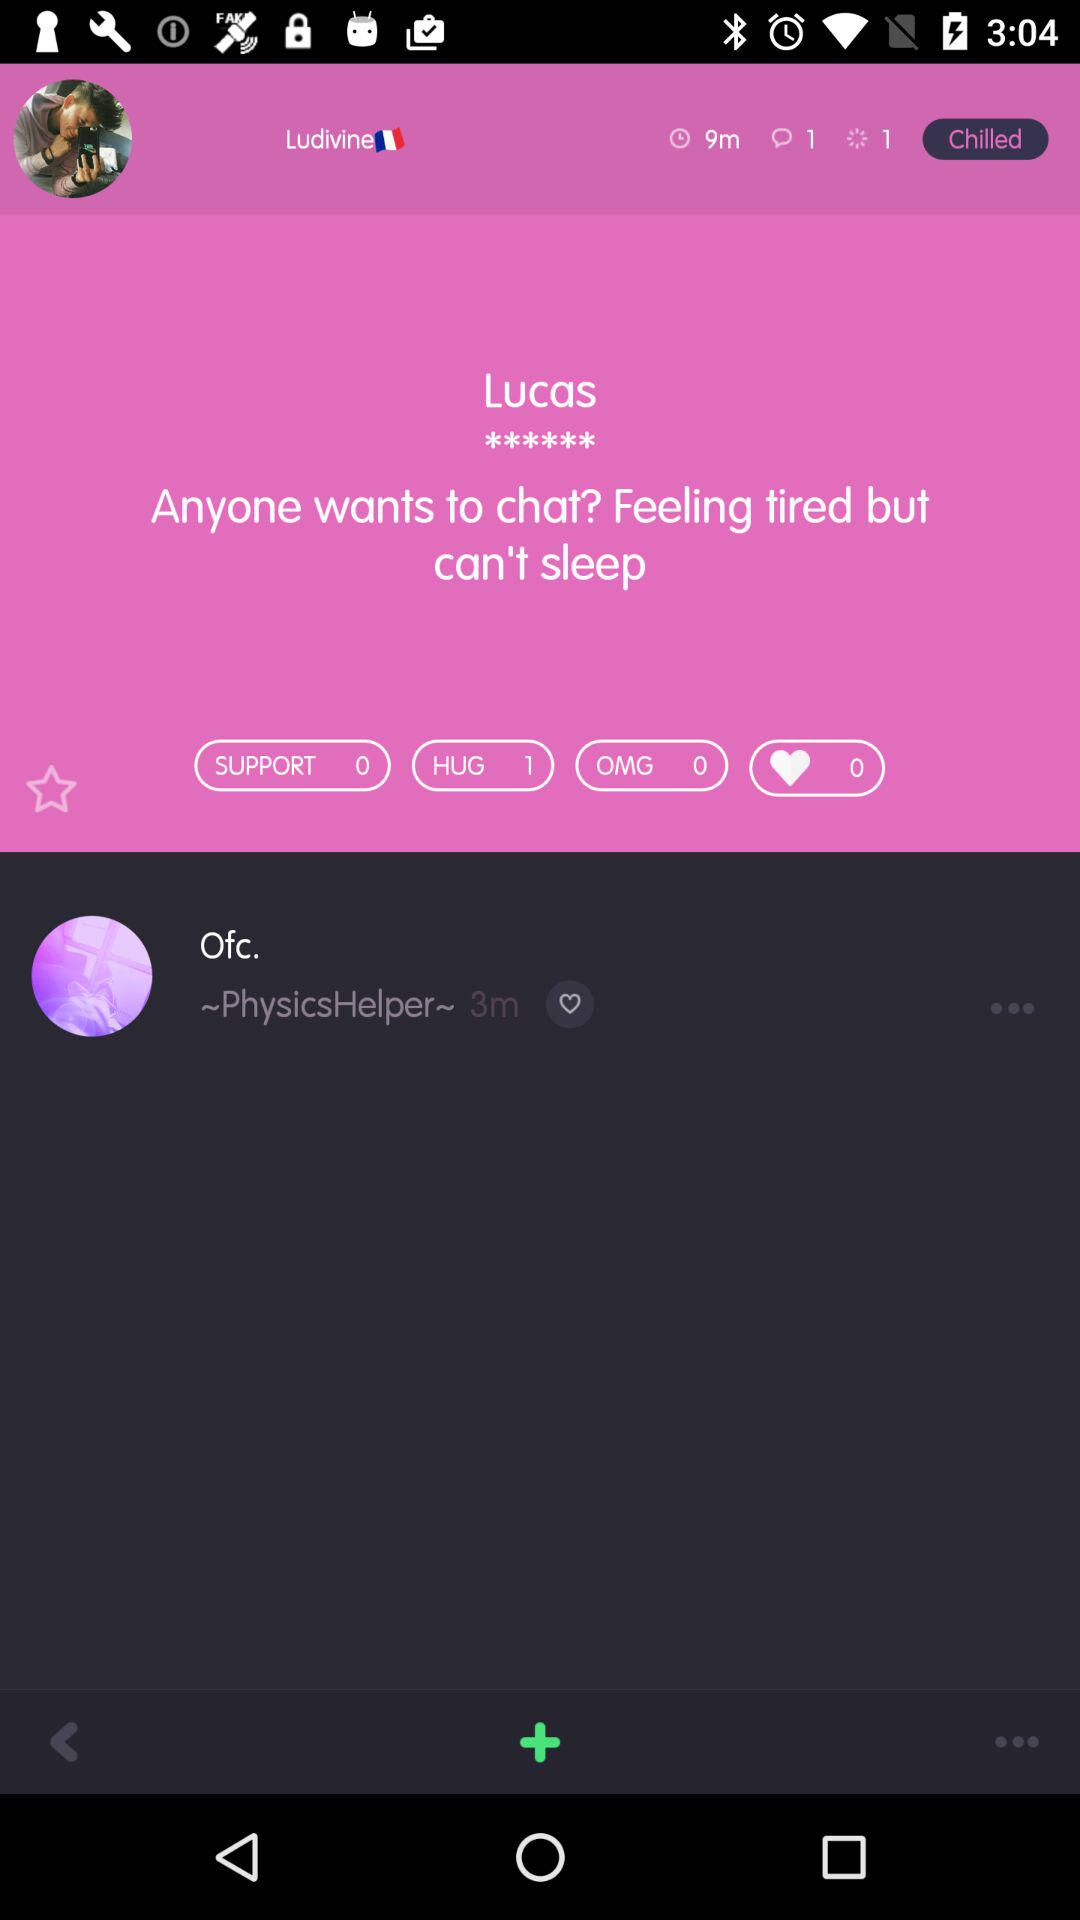How many new messages has Lucas received? Lucas has received 1 new message. 